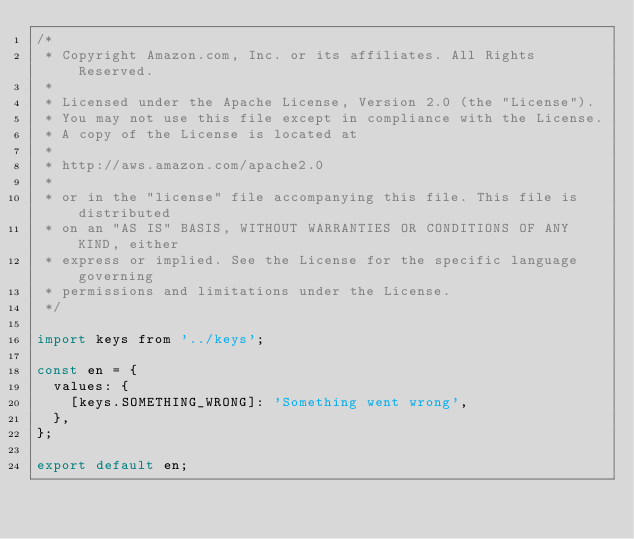<code> <loc_0><loc_0><loc_500><loc_500><_JavaScript_>/*
 * Copyright Amazon.com, Inc. or its affiliates. All Rights Reserved.
 *
 * Licensed under the Apache License, Version 2.0 (the "License").
 * You may not use this file except in compliance with the License.
 * A copy of the License is located at
 *
 * http://aws.amazon.com/apache2.0
 *
 * or in the "license" file accompanying this file. This file is distributed
 * on an "AS IS" BASIS, WITHOUT WARRANTIES OR CONDITIONS OF ANY KIND, either
 * express or implied. See the License for the specific language governing
 * permissions and limitations under the License.
 */

import keys from '../keys';

const en = {
  values: {
    [keys.SOMETHING_WRONG]: 'Something went wrong',
  },
};

export default en;
</code> 